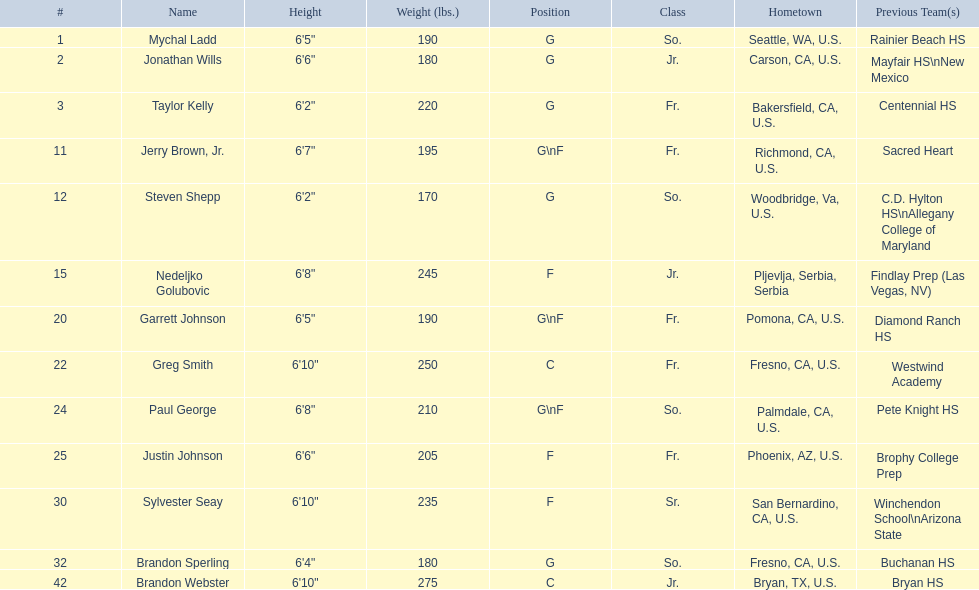Who are all of the players? Mychal Ladd, Jonathan Wills, Taylor Kelly, Jerry Brown, Jr., Steven Shepp, Nedeljko Golubovic, Garrett Johnson, Greg Smith, Paul George, Justin Johnson, Sylvester Seay, Brandon Sperling, Brandon Webster. What are their heights? 6'5", 6'6", 6'2", 6'7", 6'2", 6'8", 6'5", 6'10", 6'8", 6'6", 6'10", 6'4", 6'10". Along with taylor kelly, which other player is shorter than 6'3? Steven Shepp. 